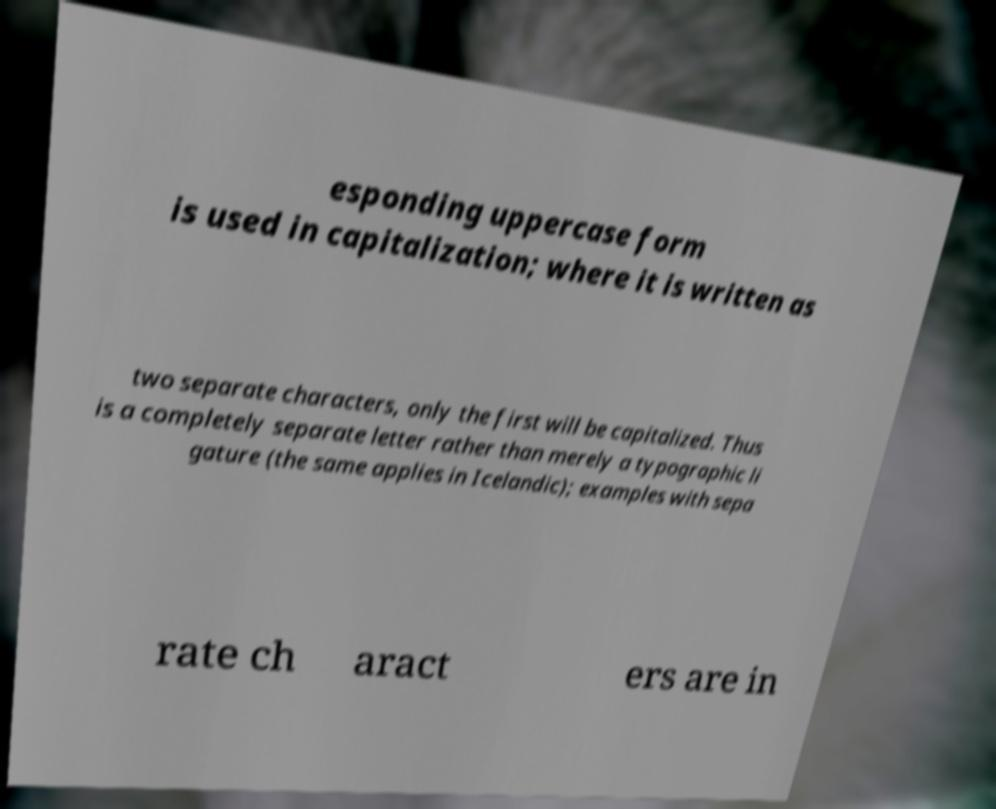Can you accurately transcribe the text from the provided image for me? esponding uppercase form is used in capitalization; where it is written as two separate characters, only the first will be capitalized. Thus is a completely separate letter rather than merely a typographic li gature (the same applies in Icelandic); examples with sepa rate ch aract ers are in 